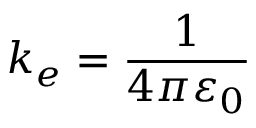Convert formula to latex. <formula><loc_0><loc_0><loc_500><loc_500>k _ { e } = { \frac { 1 } { 4 \pi \varepsilon _ { 0 } } }</formula> 